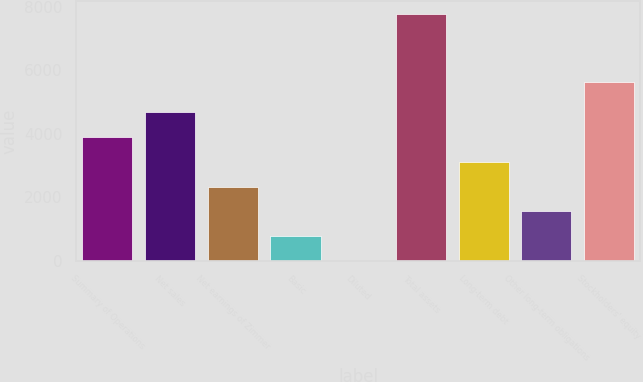<chart> <loc_0><loc_0><loc_500><loc_500><bar_chart><fcel>Summary of Operations<fcel>Net sales<fcel>Net earnings of Zimmer<fcel>Basic<fcel>Diluted<fcel>Total assets<fcel>Long-term debt<fcel>Other long-term obligations<fcel>Stockholders' equity<nl><fcel>3894.42<fcel>4672.64<fcel>2337.98<fcel>781.54<fcel>3.32<fcel>7785.5<fcel>3116.2<fcel>1559.76<fcel>5638.7<nl></chart> 